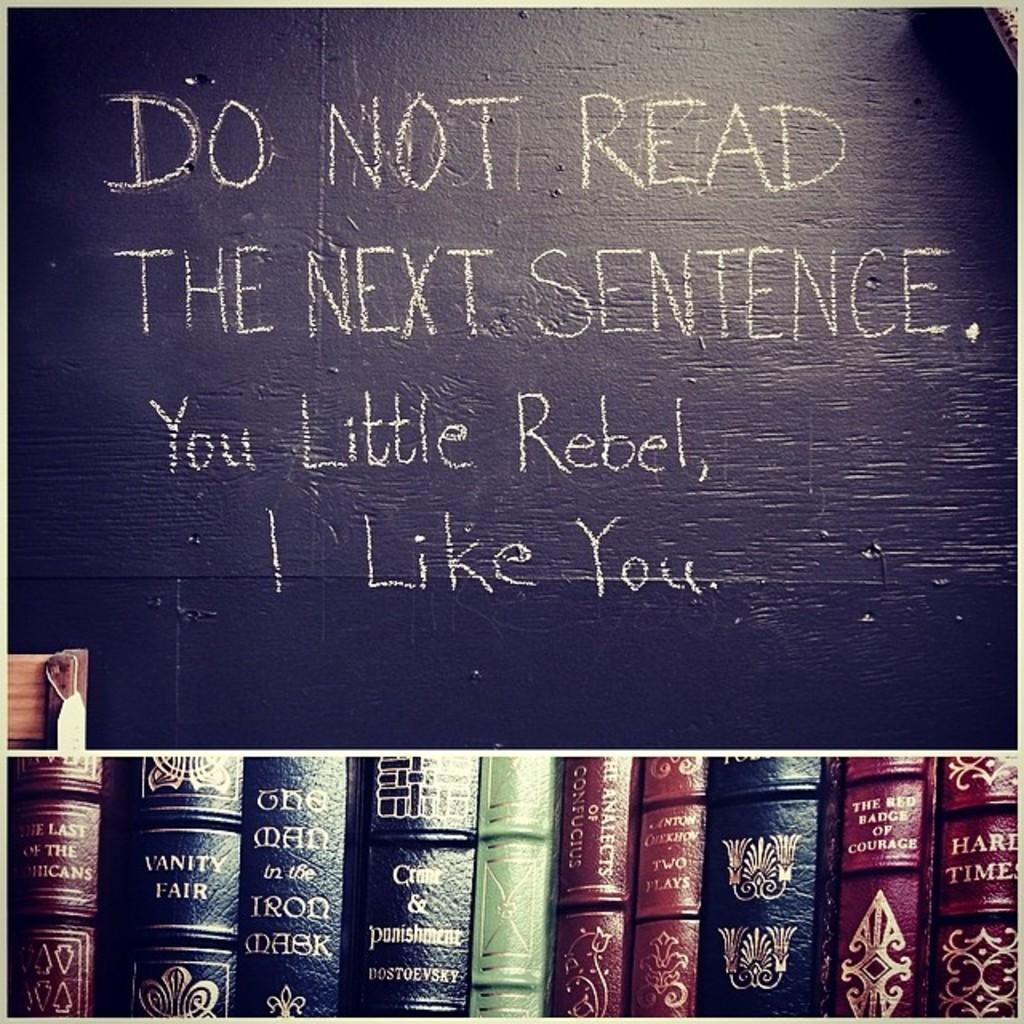<image>
Write a terse but informative summary of the picture. The blackboard warns you not to read the next sentence. 